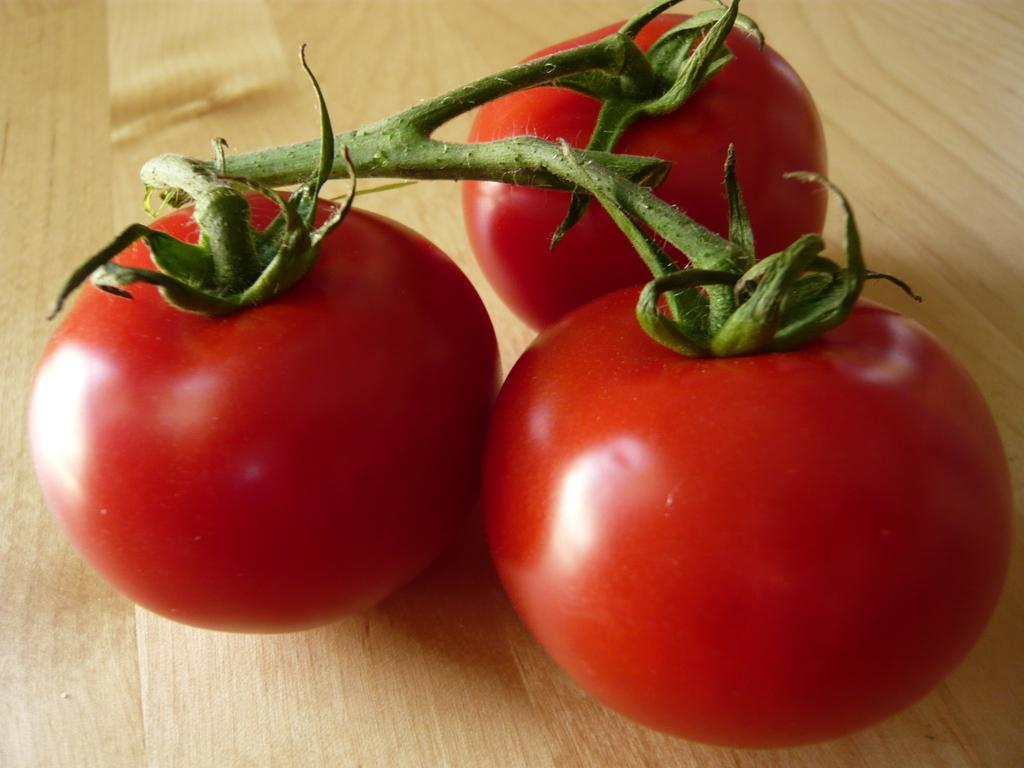How many tomatoes are visible in the image? There are 3 red color tomatoes in the image. What is the color of the tomatoes? The tomatoes are red. Where are the tomatoes placed in the image? The tomatoes are on a wooden board. Can you see a giraffe standing next to the tomatoes in the image? No, there is no giraffe present in the image. What type of pin is holding the tomatoes together in the image? There is no pin holding the tomatoes together in the image; they are simply placed on the wooden board. 